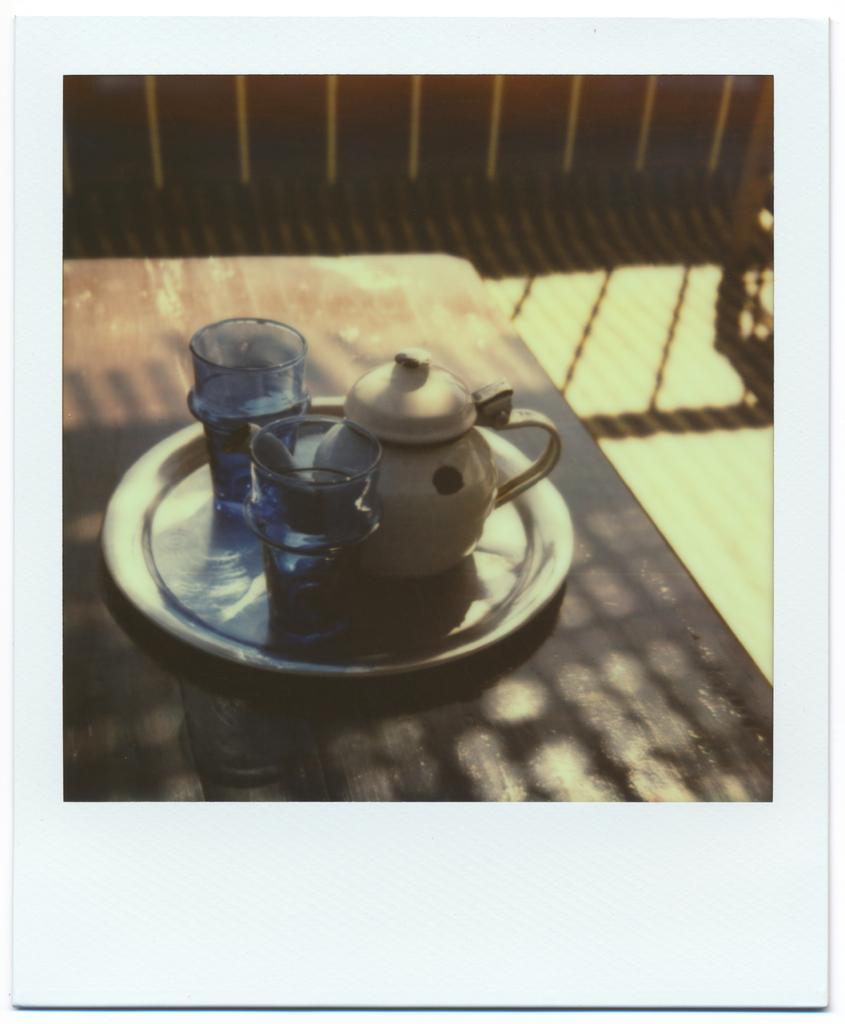Could you give a brief overview of what you see in this image? This image consists of a table. On that there is a plate. In that there are glasses, kettle. 